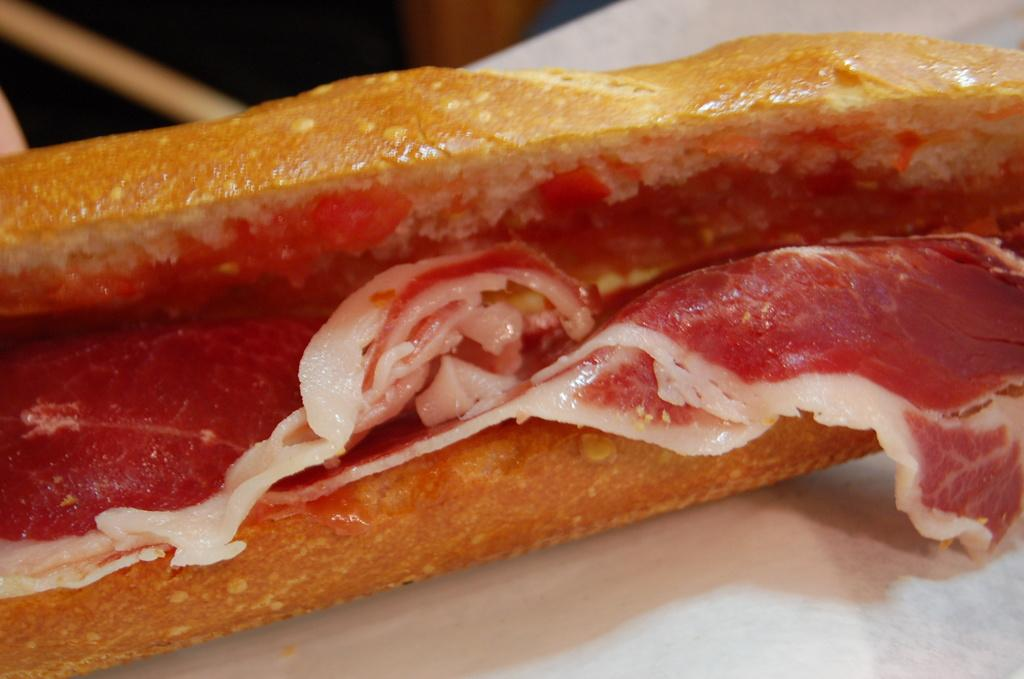What can be seen on the plate in the image? There is a food item on the plate in the image. Can you describe the plate in the image? The plate is visible in the image, but no specific details about its shape, color, or material are provided. What type of hill can be seen in the background of the image? There is no hill visible in the image; it only features a plate with a food item on it. 